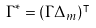<formula> <loc_0><loc_0><loc_500><loc_500>\Gamma ^ { * } = \left ( \Gamma \Delta _ { m } \right ) ^ { \intercal }</formula> 